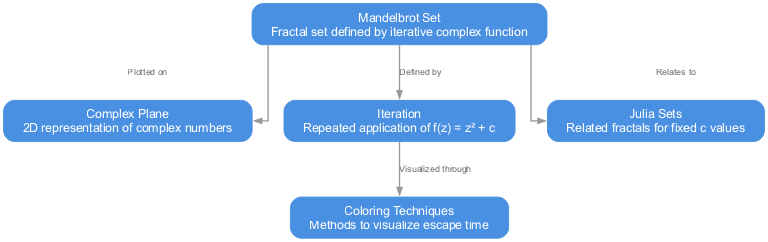What is the total number of nodes in the diagram? The diagram contains five distinct nodes: Mandelbrot Set, Complex Plane, Iteration, Julia Sets, and Coloring Techniques. To find the total, we simply count these unique items.
Answer: 5 Which node is defined by the Iteration? The Iteration node is defined by the Mandelbrot Set node, as indicated by the edge labeled "Defined by." This shows that the Mandelbrot Set is the primary concept that relies on the Iteration.
Answer: Mandelbrot Set What is the relationship between the Mandelbrot Set and the Julia Sets? The relationship is indicated by the edge labeled "Relates to," connecting the Mandelbrot Set to the Julia Sets node. This implies that they share a mathematical connection in terms of complex dynamics.
Answer: Relates to How is the Iteration visualized? The Iteration is visualized through the Coloring Techniques node, as shown by the edge labeled "Visualized through." This indicates that various coloring methods help represent the results of the Iteration process in a visual manner.
Answer: Coloring Techniques What does the Mandelbrot Set represent? The Mandelbrot Set node is described as a fractal set defined by an iterative complex function. This identifies its mathematical nature and sets it apart as a significant object in the study of complex dynamics.
Answer: Fractal set defined by iterative complex function Why is the Complex Plane important in this diagram? The Complex Plane node is crucial because the Mandelbrot Set is plotted on it, as indicated by the edge labeled "Plotted on." This shows the spatial representation context for the complex numbers involved in the Mandelbrot Set.
Answer: Plotted on 